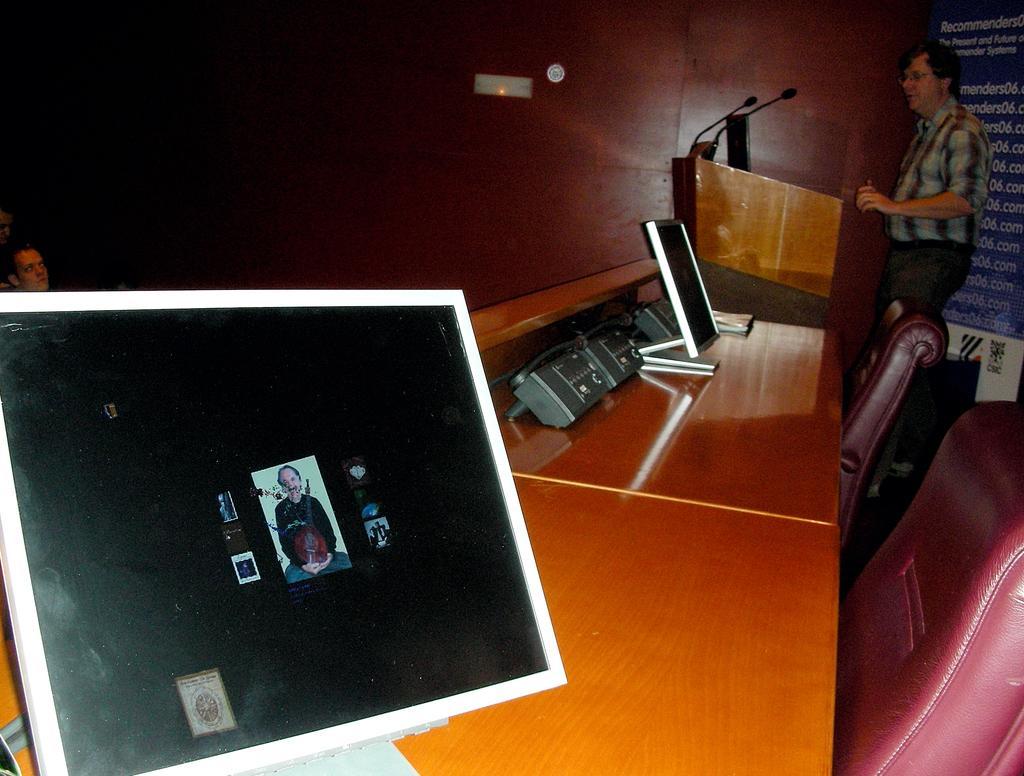In one or two sentences, can you explain what this image depicts? In this picture i could see some display boards and telephones kept on the brown table and red chairs. A person to the right is standing near the podium looks like he is giving speech in the background there is a brown colored wall. 